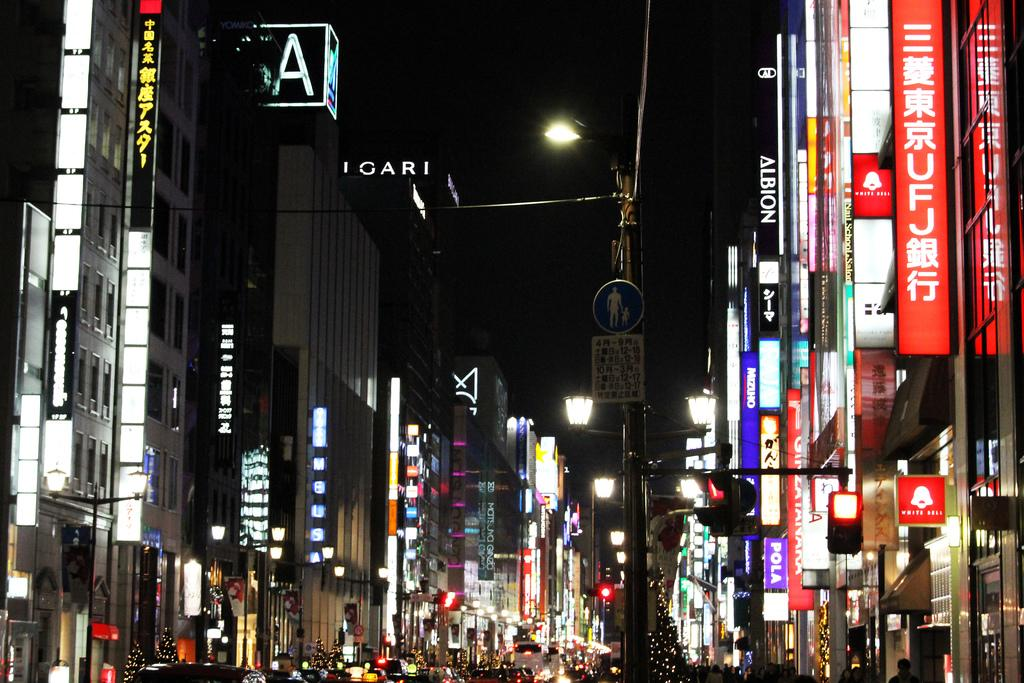What structures are located on either side of the image? There are buildings with lights on either side of the image. What is in the middle of the image? There is a sign board and a traffic signal in the middle of the image. What can be seen in the sky at the top of the image? The sky is visible at the top of the image. How much debt is the harbor incurring in the image? There is no harbor present in the image, so it is not possible to determine any debt incurred. What type of dish is the cook preparing in the image? There is no cook or dish preparation present in the image. 